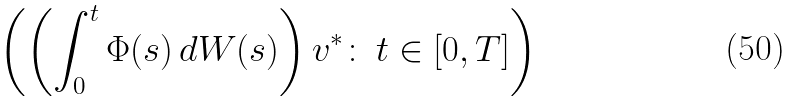<formula> <loc_0><loc_0><loc_500><loc_500>\left ( \left ( \int _ { 0 } ^ { t } \Phi ( s ) \, d W ( s ) \right ) v ^ { \ast } \colon \, t \in [ 0 , T ] \right )</formula> 